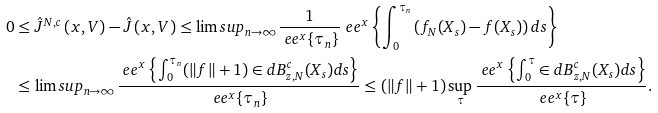Convert formula to latex. <formula><loc_0><loc_0><loc_500><loc_500>0 & \leq \hat { J } ^ { N , c } \left ( x , V \right ) - \hat { J } \left ( x , V \right ) \leq \lim s u p _ { n \to \infty } \frac { 1 } { \ e e ^ { x } \{ \tau _ { n } \} } \ e e ^ { x } \left \{ \int _ { 0 } ^ { \tau _ { n } } \left ( f _ { N } ( X _ { s } ) - f ( X _ { s } ) \right ) d s \right \} \\ & \leq \lim s u p _ { n \to \infty } \frac { \ e e ^ { x } \left \{ \int _ { 0 } ^ { \tau _ { n } } ( \| f \| + 1 ) \in d { B _ { z , N } ^ { c } } ( X _ { s } ) d s \right \} } { \ e e ^ { x } \{ \tau _ { n } \} } \leq ( \| f \| + 1 ) \sup _ { \tau } \frac { \ e e ^ { x } \left \{ \int _ { 0 } ^ { \tau } \in d { B _ { z , N } ^ { c } } ( X _ { s } ) d s \right \} } { \ e e ^ { x } \{ \tau \} } .</formula> 